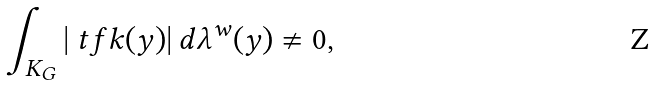<formula> <loc_0><loc_0><loc_500><loc_500>\int _ { K _ { G } } | \ t f k ( y ) | \, d \lambda ^ { w } ( y ) \not = 0 ,</formula> 